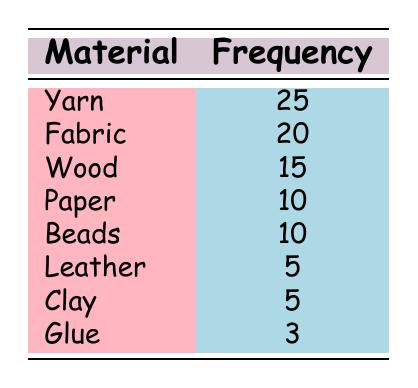What is the most common material used in handicrafts among retirees? From the table, Yarn has the highest frequency at 25, making it the most common material.
Answer: Yarn How many retirees use Fabric for their handicrafts? According to the table, the frequency of Fabric is listed as 20.
Answer: 20 Is there a material used by more than 15 retirees but less than 20? The frequency for Wood is 15, which is neither greater than 15 nor lesser than 20. Since there are no materials that meet the criteria, the answer is no.
Answer: No What is the total frequency of all materials used? Summing the frequencies: 25 (Yarn) + 20 (Fabric) + 15 (Wood) + 10 (Paper) + 10 (Beads) + 5 (Leather) + 5 (Clay) + 3 (Glue) gives us a total of 93.
Answer: 93 How many more retirees craft with Yarn than with Glue? The frequency for Yarn is 25 and for Glue is 3. Subtracting these gives 25 - 3 = 22.
Answer: 22 Is the frequency of Beads equal to that of Paper? Both Beads and Paper have a frequency of 10. Therefore, they are equal, which means the answer is yes.
Answer: Yes What is the average frequency of the materials listed? To find the average, sum the frequencies (93 from the previous question) and divide by the number of materials (8). Thus, the average is 93 / 8 = 11.625.
Answer: 11.625 Which material has the least frequency, and how many retirees use it? The materials with the least frequency are Glue, Leather, and Clay, all with a frequency of 5 or 3 for Glue. Glue has the least frequency at 3.
Answer: Glue, 3 